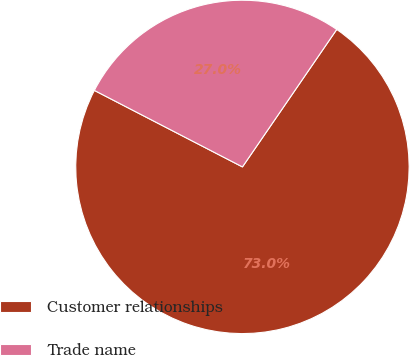<chart> <loc_0><loc_0><loc_500><loc_500><pie_chart><fcel>Customer relationships<fcel>Trade name<nl><fcel>73.02%<fcel>26.98%<nl></chart> 